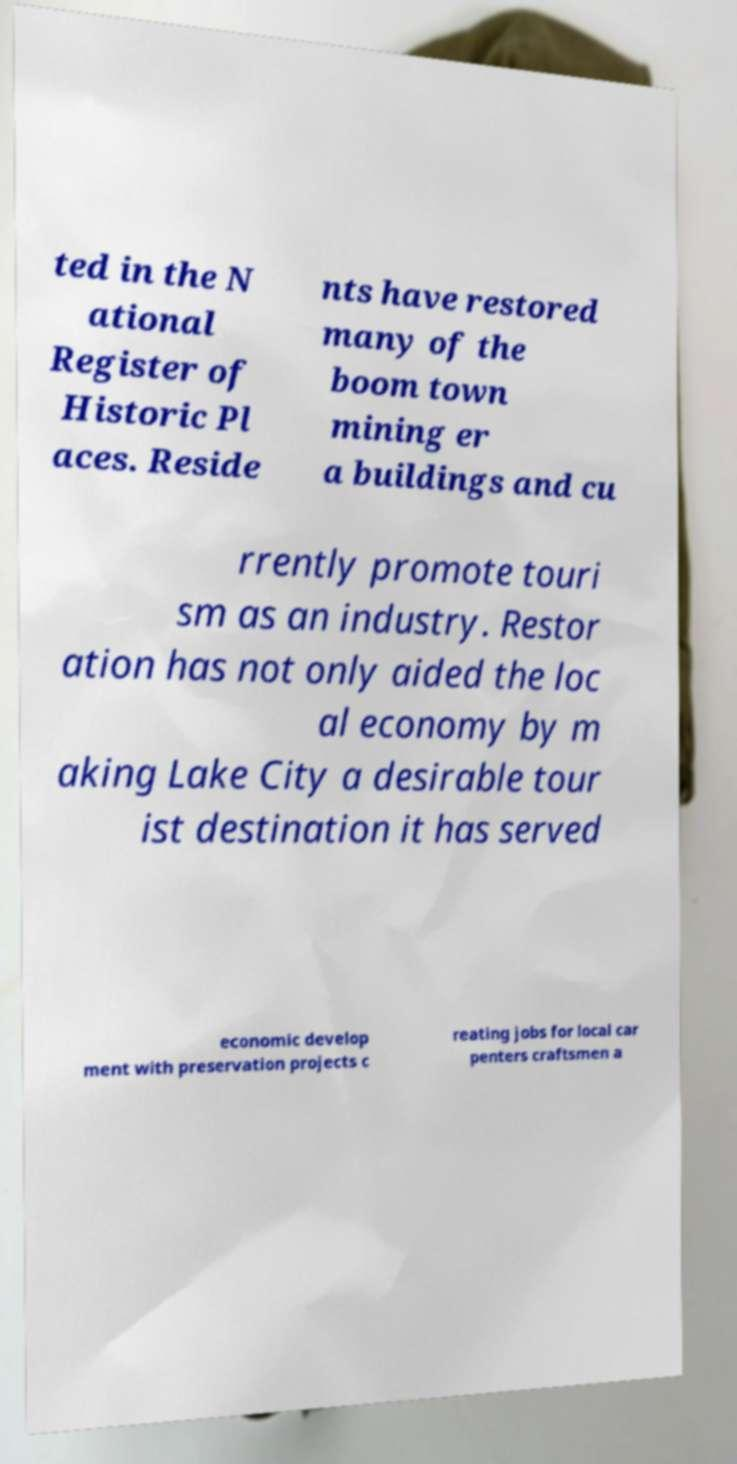What messages or text are displayed in this image? I need them in a readable, typed format. ted in the N ational Register of Historic Pl aces. Reside nts have restored many of the boom town mining er a buildings and cu rrently promote touri sm as an industry. Restor ation has not only aided the loc al economy by m aking Lake City a desirable tour ist destination it has served economic develop ment with preservation projects c reating jobs for local car penters craftsmen a 